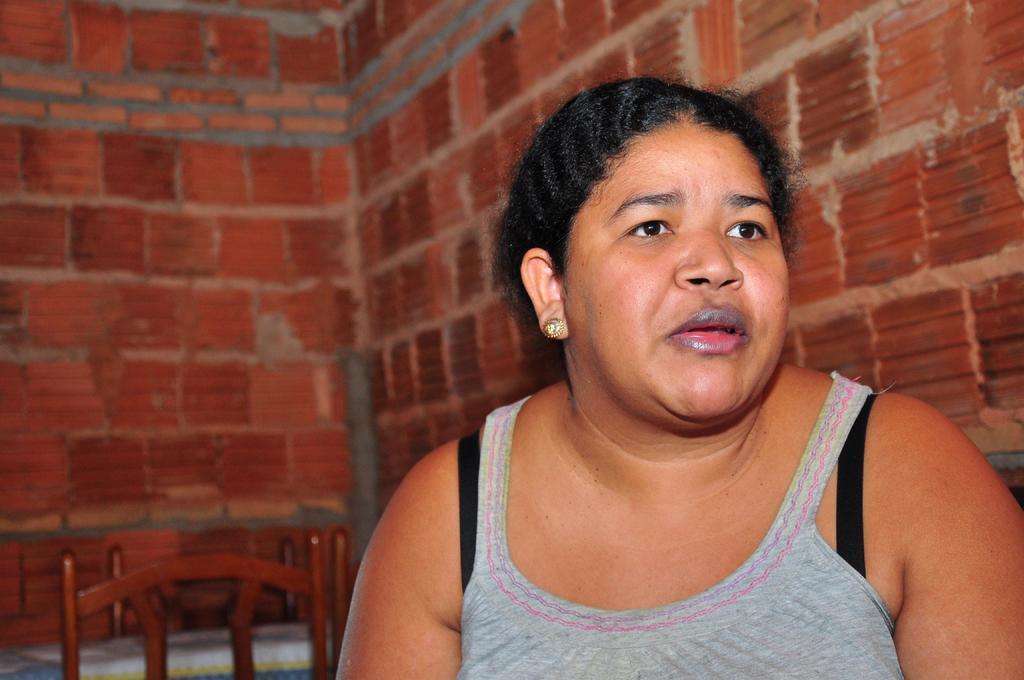Can you describe this image briefly? In the image we can see a woman. Behind her there are some chairs and wall. 